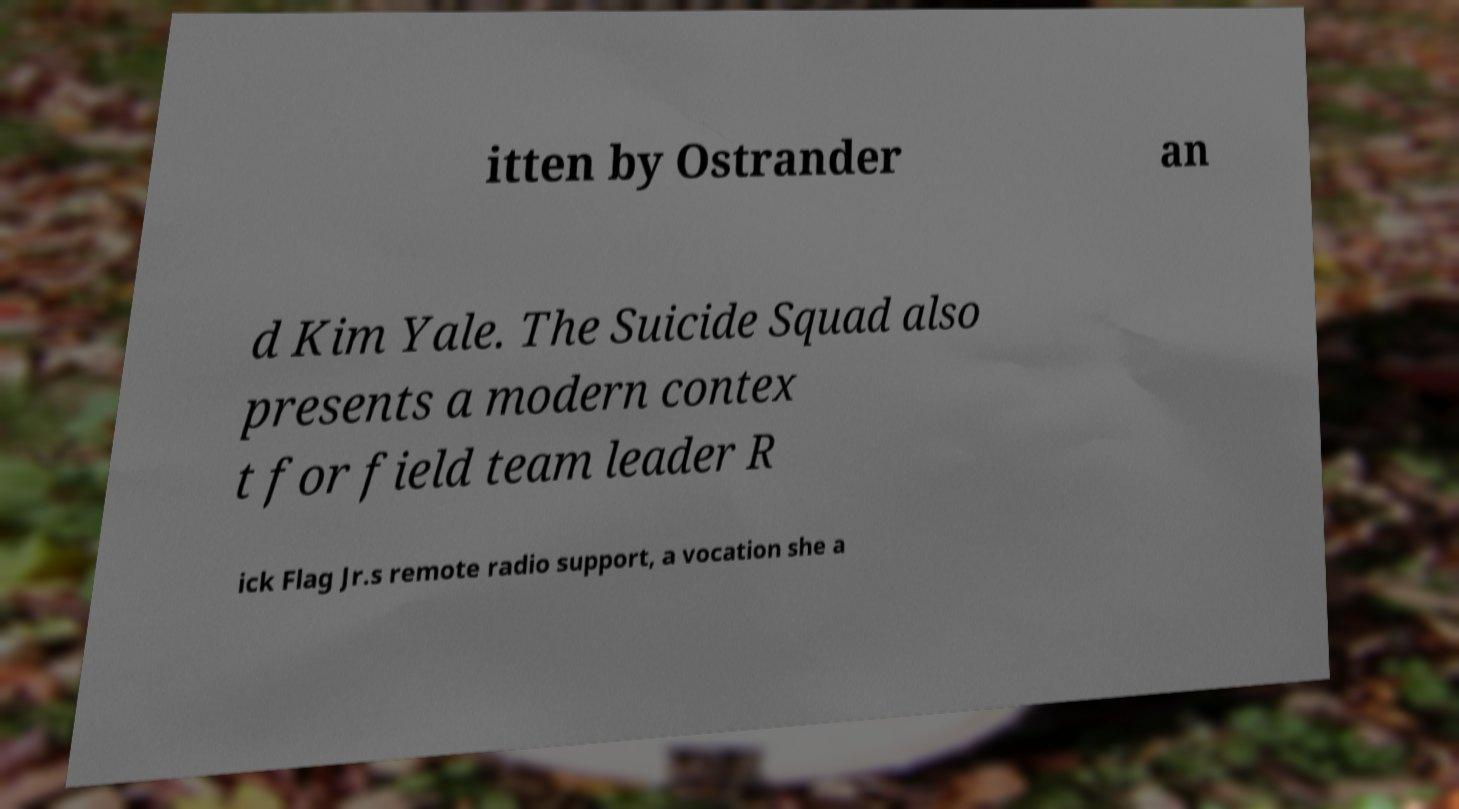Can you accurately transcribe the text from the provided image for me? itten by Ostrander an d Kim Yale. The Suicide Squad also presents a modern contex t for field team leader R ick Flag Jr.s remote radio support, a vocation she a 